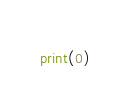Convert code to text. <code><loc_0><loc_0><loc_500><loc_500><_Python_>print(0)</code> 